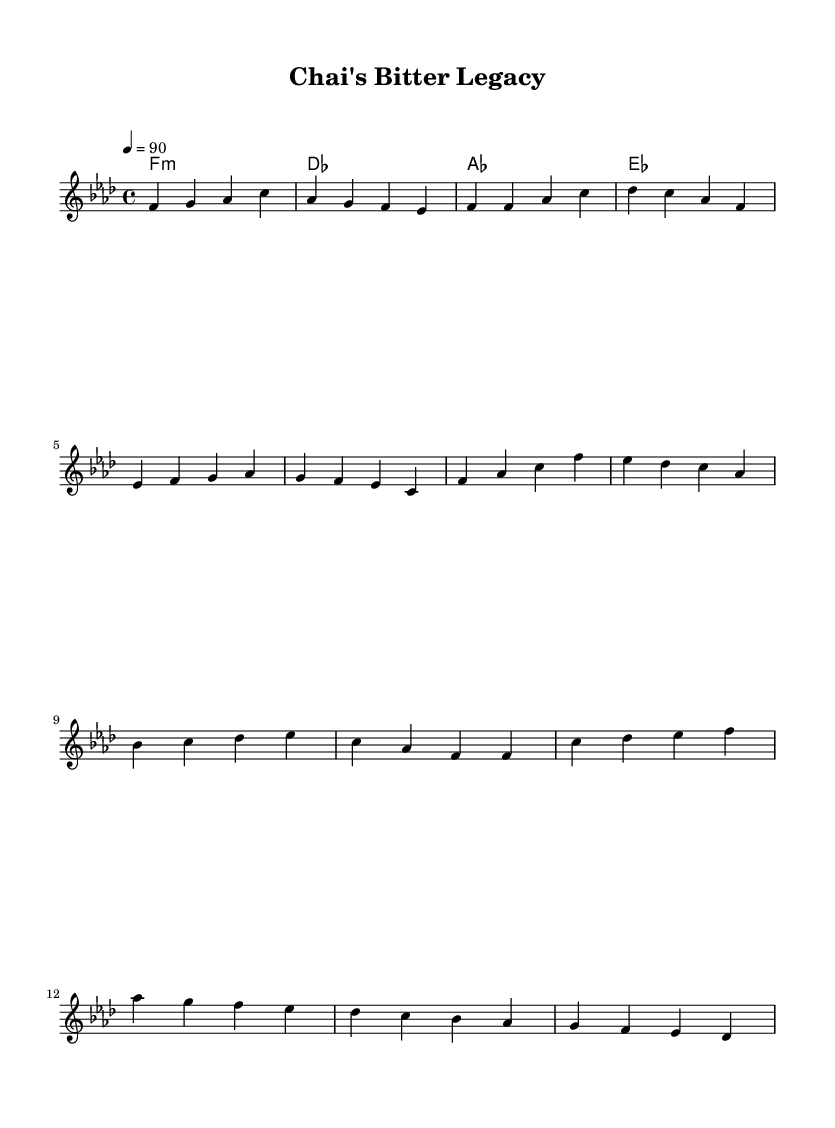What is the key signature of this music? The key signature is F minor, which includes four flats (B, E, A, D). This is indicated at the beginning of the staff.
Answer: F minor What is the time signature of the piece? The time signature is 4/4, which means there are four beats in each measure and that the quarter note gets one beat. This is also noted at the beginning of the sheet music.
Answer: 4/4 What is the tempo marking given in the sheet music? The tempo marking is 90 beats per minute, indicated by the tempo directive "4 = 90" at the start. This means the music should be played at this speed.
Answer: 90 How many measures are in the verse section? There are four measures in the verse section. This is determined by counting the measures from "f f as c" to "g f es c".
Answer: 4 What type of music does this piece represent? The piece represents hip hop, highlighted by the lyrical focus on socially conscious themes addressing economic disparities due to colonial exploitation.
Answer: Hip hop Which chord follows F minor in the harmony section? The chord following F minor in the harmony section is D flat major, as indicated in the chord progression sequence.
Answer: D flat major 